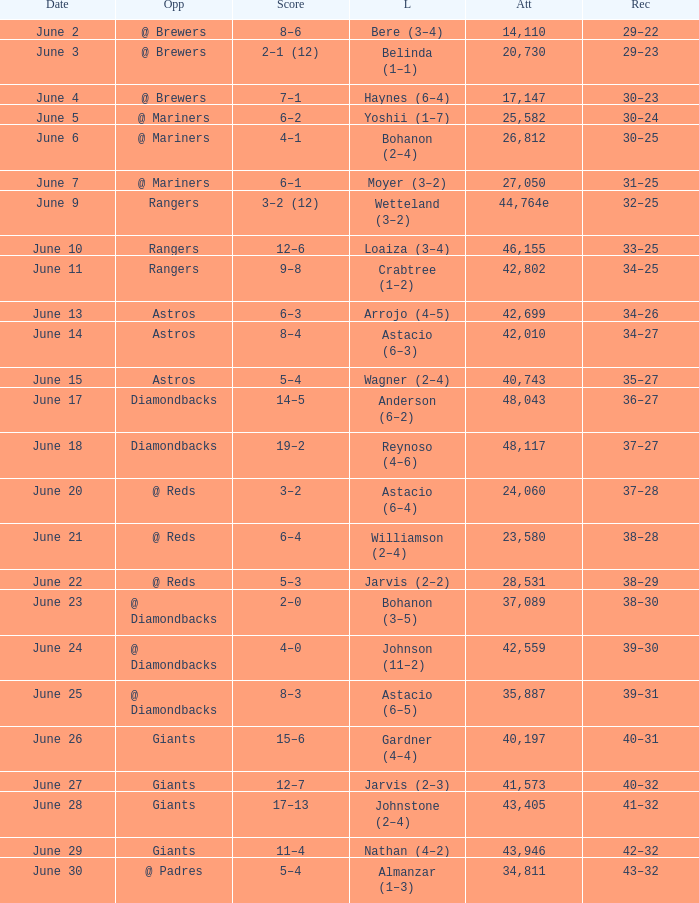What's the record when the attendance was 41,573? 40–32. 